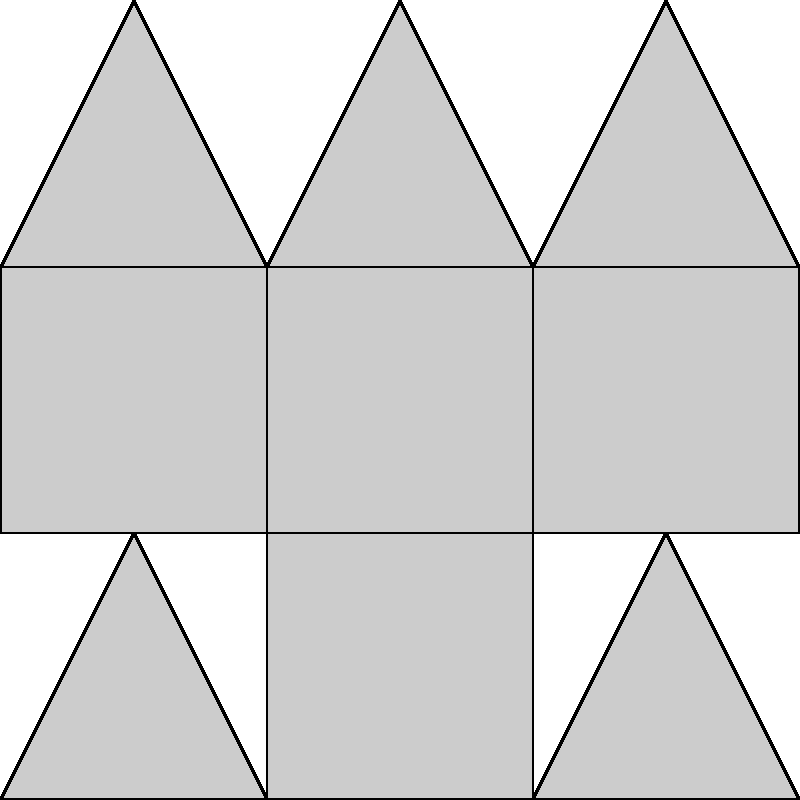Qual das seguintes opções representa corretamente a planificação do poliedro complexo mostrado à esquerda?

A) A planificação mostrada à direita
B) A planificação mostrada à direita, mas com uma face triangular adicional
C) A planificação mostrada à direita, mas com uma face quadrada a menos
D) A planificação mostrada à direita, mas com todas as faces triangulares Para determinar se a planificação mostrada à direita corresponde corretamente ao poliedro complexo à esquerda, vamos seguir os seguintes passos:

1. Analisar o poliedro:
   - O poliedro tem uma base quadrada.
   - Possui 4 faces retangulares nas laterais.
   - Tem 4 faces triangulares no topo, formando uma pirâmide.

2. Contar as faces na planificação:
   - 1 face quadrada (base)
   - 4 faces retangulares (laterais)
   - 4 faces triangulares (topo)

3. Verificar a disposição das faces:
   - A face quadrada da base está conectada a 4 faces retangulares.
   - Cada face retangular está conectada a uma face triangular.
   - As 4 faces triangulares estão dispostas de forma a se unirem no topo.

4. Comparar com o poliedro original:
   - O número de faces corresponde exatamente.
   - A disposição das faces permite a reconstrução do poliedro original.

5. Avaliar as alternativas:
   A) Corresponde exatamente ao que foi analisado.
   B) Incorreta, pois não há face triangular adicional.
   C) Incorreta, pois não falta nenhuma face quadrada.
   D) Incorreta, pois há faces quadradas e retangulares na planificação.

Portanto, a planificação mostrada à direita representa corretamente o poliedro complexo.
Answer: A 